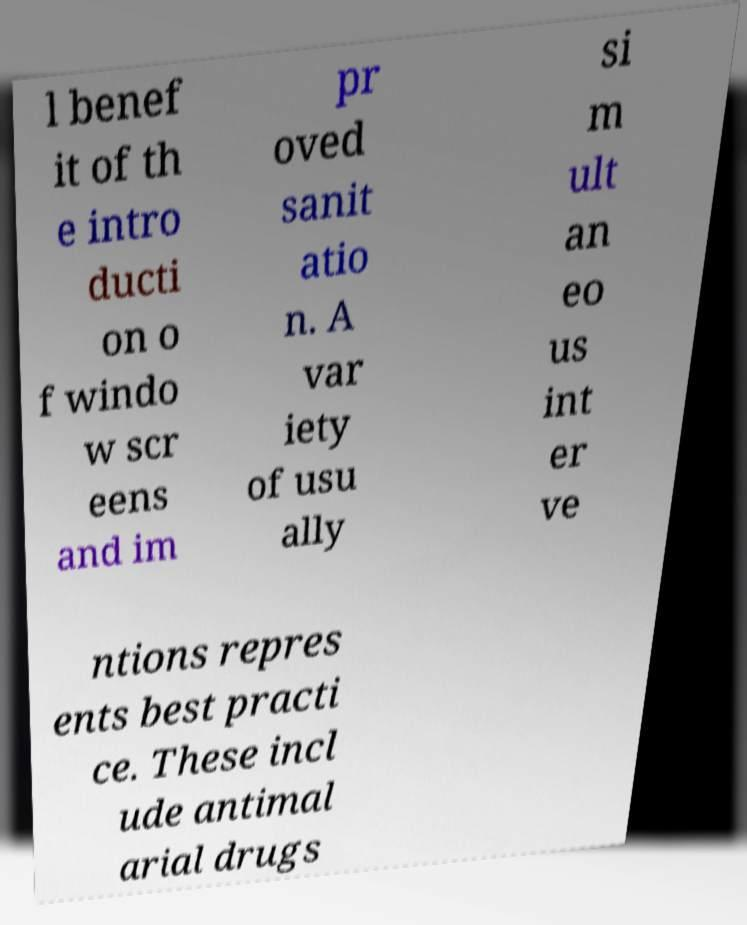Could you assist in decoding the text presented in this image and type it out clearly? l benef it of th e intro ducti on o f windo w scr eens and im pr oved sanit atio n. A var iety of usu ally si m ult an eo us int er ve ntions repres ents best practi ce. These incl ude antimal arial drugs 